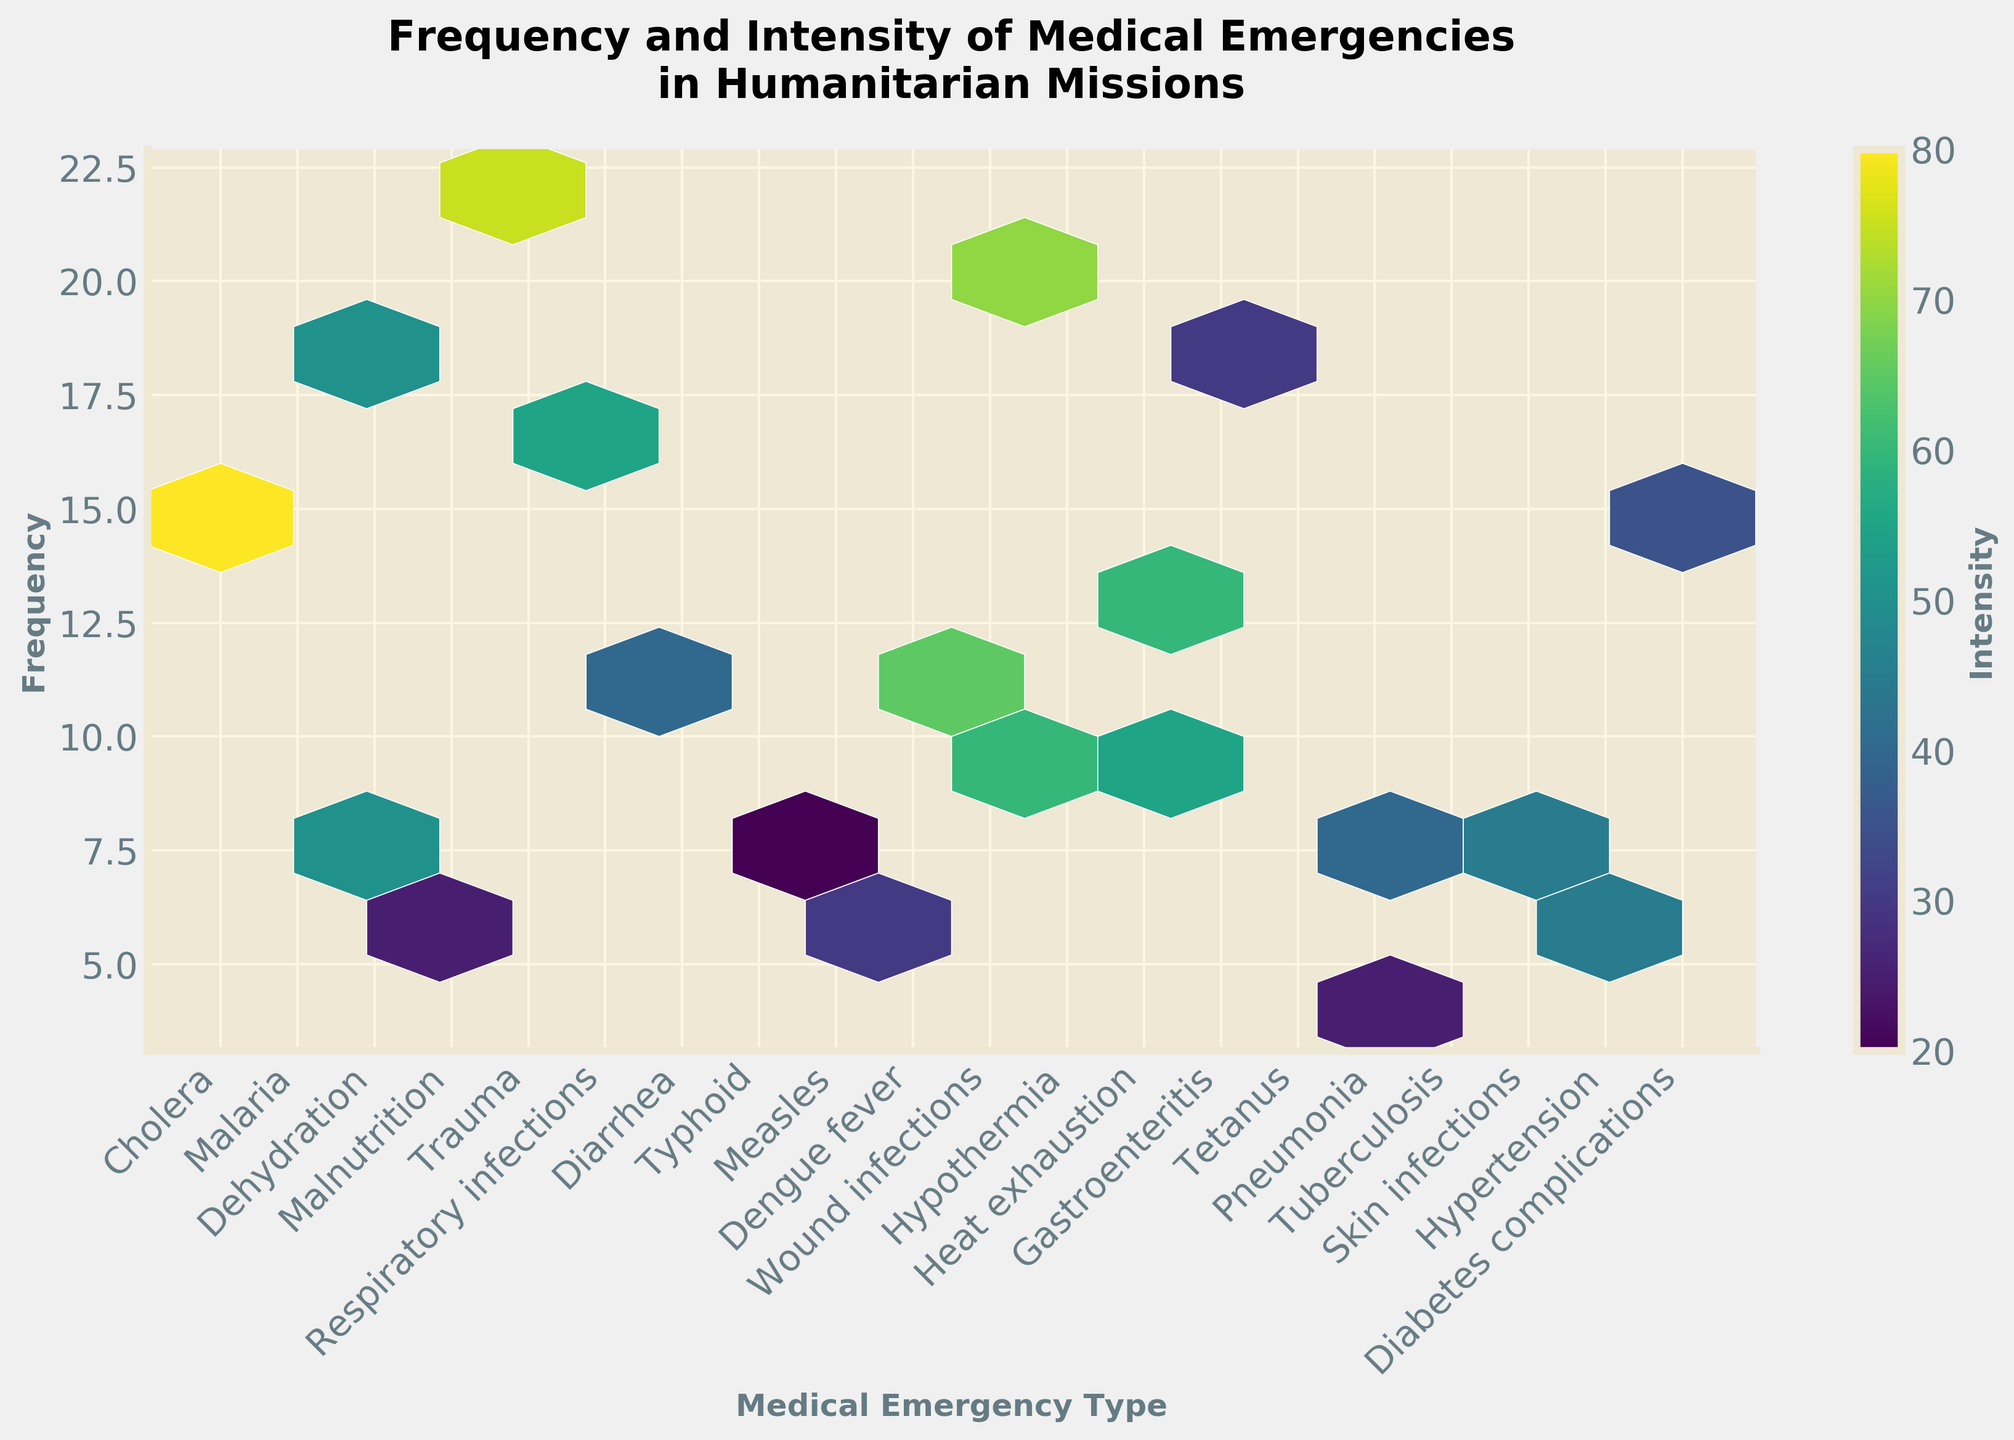Which type of medical emergency has the highest recorded frequency? The plot displays the frequency on the y-axis, and by observing the highest y-value among the different emergency types, dehydration has the highest frequency, peaking at 22 cases.
Answer: Dehydration What is the title of the plot? The title of the plot is located at the top and provides an overview of the figure.
Answer: Frequency and Intensity of Medical Emergencies in Humanitarian Missions Which two medical emergencies have similar intensity levels but different frequencies? By identifying the hexagons with close color intensities but different y-axis values, measles and pneumonia both show an intensity around 60, but measles has a frequency of 9 and pneumonia has a frequency of 13.
Answer: Measles and pneumonia Which medical emergency shows the lowest intensity? The intensity is shown by the color gradient in the plot. The emergency with the palest color indicates the lowest intensity; hypertension appears the palest with an intensity value of 20.
Answer: Hypertension How does the frequency of malaria compare to typhoid? By comparing the y-values corresponding to malaria and typhoid, we can see that malaria has a frequency of 12 while typhoid has a frequency of 6.
Answer: Malaria is more frequent than typhoid How many grids display an intensity higher than 50? By examining the plot and counting the number of hexagonal bins with a color darker than the mid-range hue (which aligns with an intensity of around 50), there are 14 bins with an intensity value higher than 50.
Answer: 14 What is the average intensity of malnutrition and diarrhea? The intensities for malnutrition and diarrhea are 70 and 75, respectively. The average would be calculated as (70 + 75) / 2 = 72.5.
Answer: 72.5 What is the overall trend seen in frequency and intensity for respiratory infections? By analyzing both the position and color gradient for respiratory infections, it has a moderate frequency of 10 and a moderate-high intensity of 55.
Answer: Moderate frequency and moderate-high intensity What is the combined intensity of cholera, malaria, and dehydration? Summing the intensities for cholera (80), malaria (65), and dehydration (50) gives a total intensity of 80 + 65 + 50 = 195.
Answer: 195 